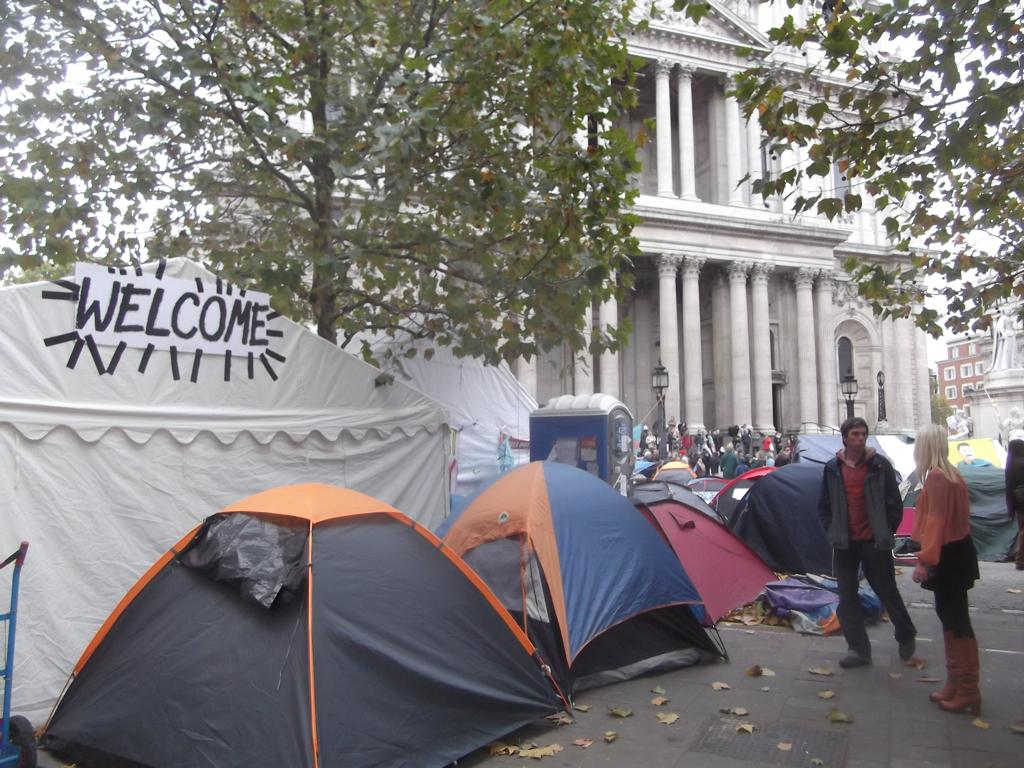How many people are standing in the image? There are two persons standing in the image. What structures can be seen in the image? There are tents, lights, poles, trees, and buildings in the image. Can you describe the group of people in the image? There is a group of people standing in the image. What is visible in the background of the image? The sky is visible in the background of the image. What invention is being demonstrated by the girl in the image? There is no girl present in the image, and therefore no invention can be demonstrated. 